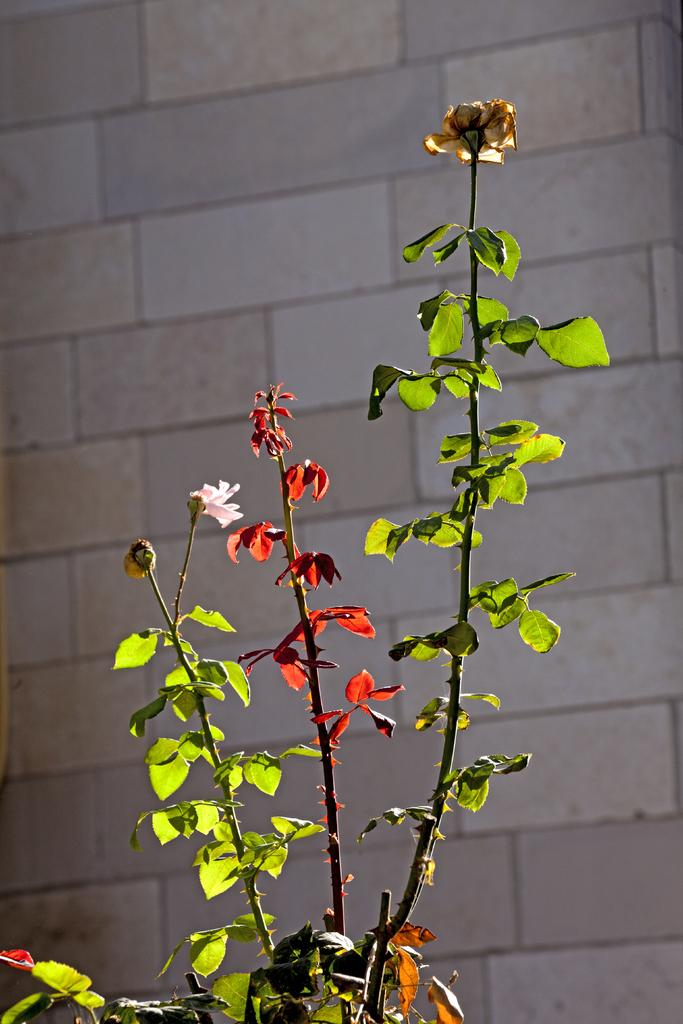What type of vegetation can be seen in the image? There are green leaves, red leaves, and flowers in the image. Can you describe the colors of the leaves in the image? The leaves in the image are green and red. What else is present in the image besides the vegetation? There is a wall in the background of the image. What type of car can be seen driving through the flowers in the image? There is no car present in the image; it only features vegetation and a wall in the background. 